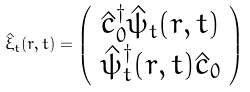<formula> <loc_0><loc_0><loc_500><loc_500>\hat { \xi } _ { t } ( { r } , t ) = \left ( \begin{array} { c } \hat { c } _ { 0 } ^ { \dag } \hat { \psi } _ { t } ( { r } , t ) \\ \hat { \psi } _ { t } ^ { \dag } ( { r } , t ) \hat { c } _ { 0 } \end{array} \right )</formula> 